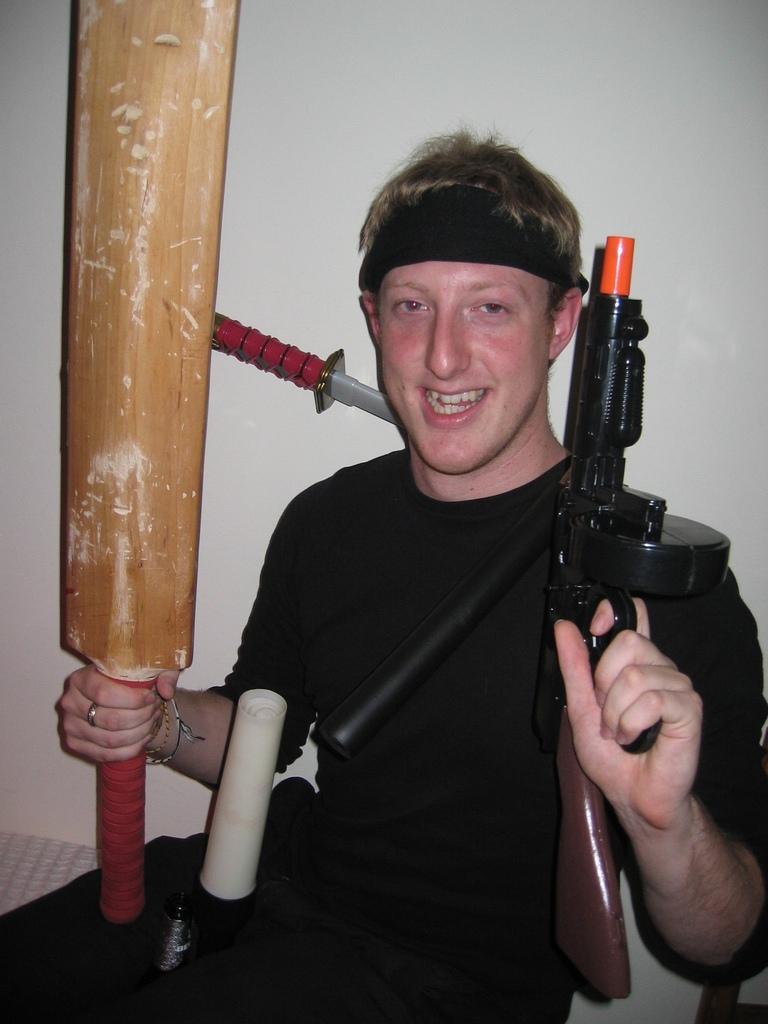What is the main subject of the image? There is a person in the image. What is the person holding in their hands? The person is holding a bat and a gun. What can be seen in the middle of the image? There are other objects visible in the middle of the image. What is behind the person in the image? There is a wall behind the person. Can you see any volcanoes erupting in the image? No, there are no volcanoes present in the image. How many rabbits can be seen hopping around in the image? There are no rabbits present in the image. 